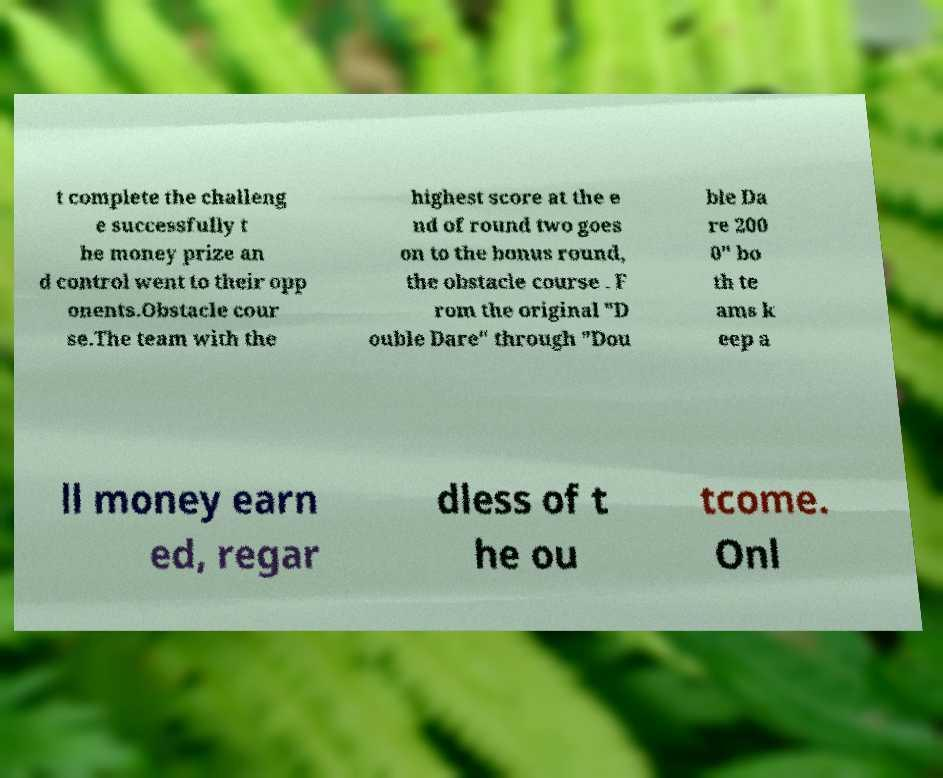I need the written content from this picture converted into text. Can you do that? t complete the challeng e successfully t he money prize an d control went to their opp onents.Obstacle cour se.The team with the highest score at the e nd of round two goes on to the bonus round, the obstacle course . F rom the original "D ouble Dare" through "Dou ble Da re 200 0" bo th te ams k eep a ll money earn ed, regar dless of t he ou tcome. Onl 